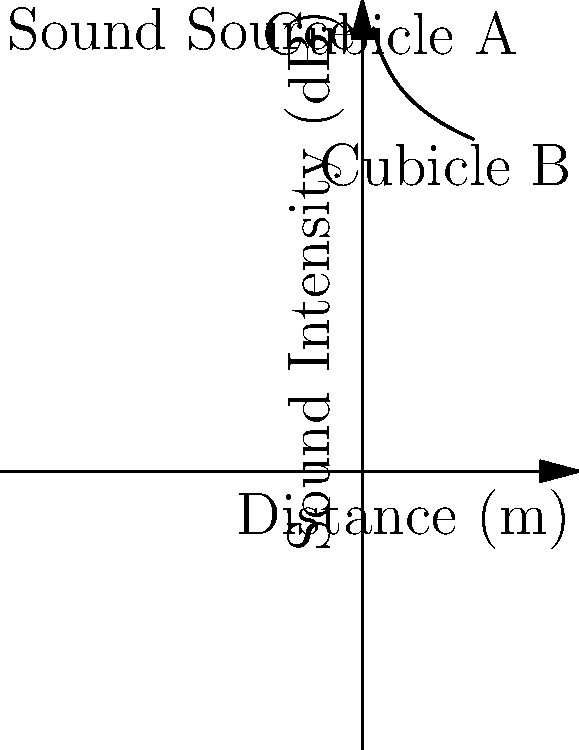In your open-plan office, a new sound system is being tested. The graph shows the sound intensity level versus distance from the source. If the sound intensity at Cubicle A (5m from the source) is 74 dB, what is the approximate sound intensity at Cubicle B (15m from the source)? How might this affect productivity and communication in your modern workplace design? To solve this problem, we'll use the inverse square law for sound intensity and the decibel scale:

1) The inverse square law states that sound intensity is inversely proportional to the square of the distance from the source.

2) On the decibel scale, every doubling of distance results in a 6 dB decrease in sound intensity level.

3) The distance ratio between Cubicle B and Cubicle A is 15m / 5m = 3.

4) To calculate the dB difference, we use the formula:
   $\Delta dB = 20 \log_{10}(\frac{d_2}{d_1})$
   
   $\Delta dB = 20 \log_{10}(3) \approx 9.54$ dB

5) Therefore, the sound intensity at Cubicle B will be approximately 9.54 dB less than at Cubicle A.

6) Sound intensity at Cubicle B = 74 dB - 9.54 dB ≈ 64.5 dB

Regarding workplace design:
- 64.5 dB is still within the range of normal conversation (60-70 dB).
- This level may allow for reasonable communication without excessive disturbance.
- However, it might affect concentration for tasks requiring intense focus.
- Consider using sound-absorbing materials or white noise systems to improve acoustic comfort.
Answer: 64.5 dB; may allow communication but could affect concentration for focused tasks. 